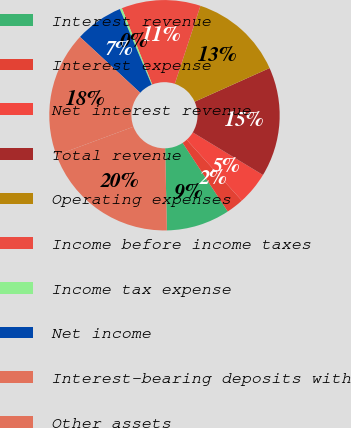<chart> <loc_0><loc_0><loc_500><loc_500><pie_chart><fcel>Interest revenue<fcel>Interest expense<fcel>Net interest revenue<fcel>Total revenue<fcel>Operating expenses<fcel>Income before income taxes<fcel>Income tax expense<fcel>Net income<fcel>Interest-bearing deposits with<fcel>Other assets<nl><fcel>8.92%<fcel>2.46%<fcel>4.61%<fcel>15.39%<fcel>13.23%<fcel>11.08%<fcel>0.31%<fcel>6.77%<fcel>17.54%<fcel>19.69%<nl></chart> 